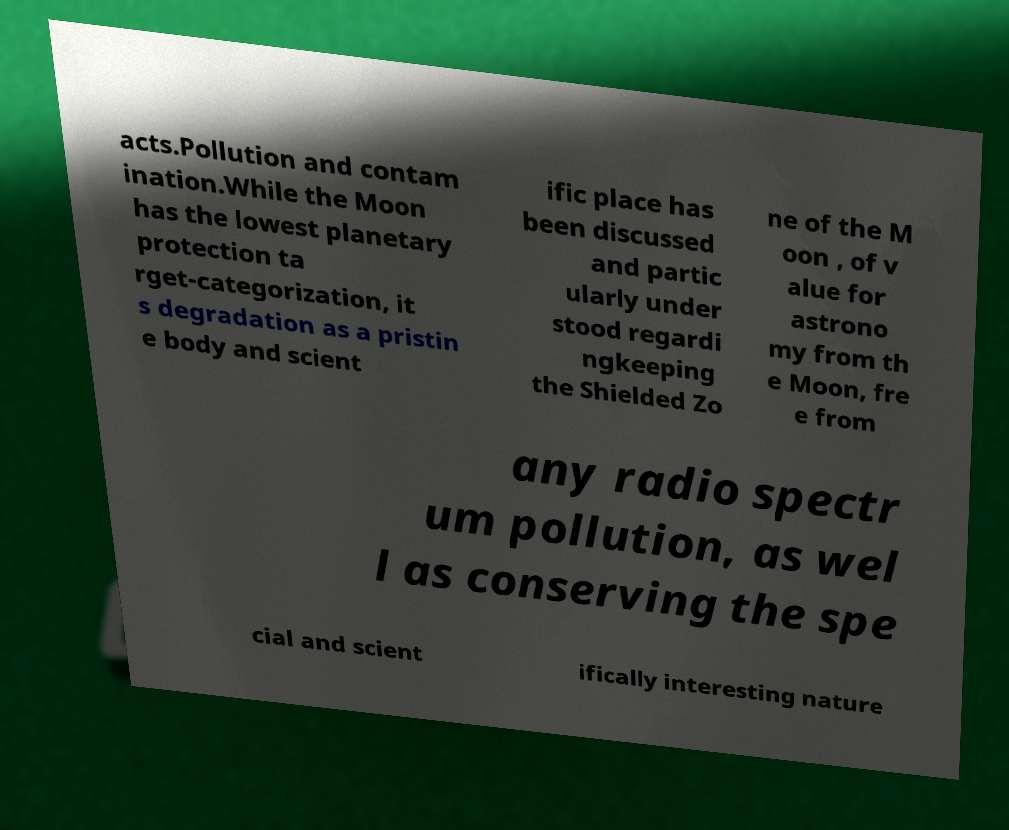I need the written content from this picture converted into text. Can you do that? acts.Pollution and contam ination.While the Moon has the lowest planetary protection ta rget-categorization, it s degradation as a pristin e body and scient ific place has been discussed and partic ularly under stood regardi ngkeeping the Shielded Zo ne of the M oon , of v alue for astrono my from th e Moon, fre e from any radio spectr um pollution, as wel l as conserving the spe cial and scient ifically interesting nature 